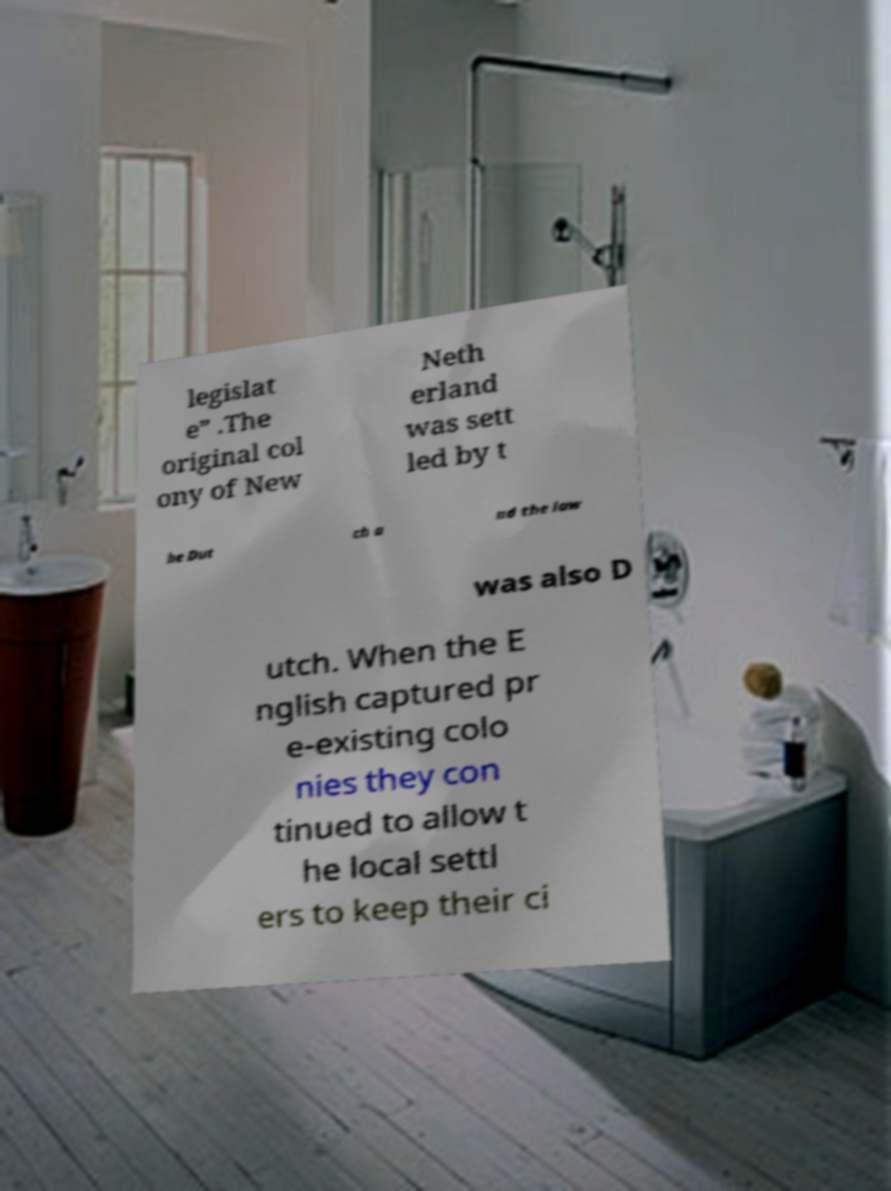I need the written content from this picture converted into text. Can you do that? legislat e” .The original col ony of New Neth erland was sett led by t he Dut ch a nd the law was also D utch. When the E nglish captured pr e-existing colo nies they con tinued to allow t he local settl ers to keep their ci 